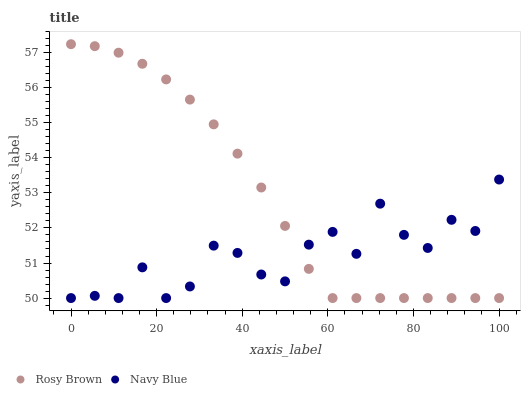Does Navy Blue have the minimum area under the curve?
Answer yes or no. Yes. Does Rosy Brown have the maximum area under the curve?
Answer yes or no. Yes. Does Rosy Brown have the minimum area under the curve?
Answer yes or no. No. Is Rosy Brown the smoothest?
Answer yes or no. Yes. Is Navy Blue the roughest?
Answer yes or no. Yes. Is Rosy Brown the roughest?
Answer yes or no. No. Does Navy Blue have the lowest value?
Answer yes or no. Yes. Does Rosy Brown have the highest value?
Answer yes or no. Yes. Does Rosy Brown intersect Navy Blue?
Answer yes or no. Yes. Is Rosy Brown less than Navy Blue?
Answer yes or no. No. Is Rosy Brown greater than Navy Blue?
Answer yes or no. No. 